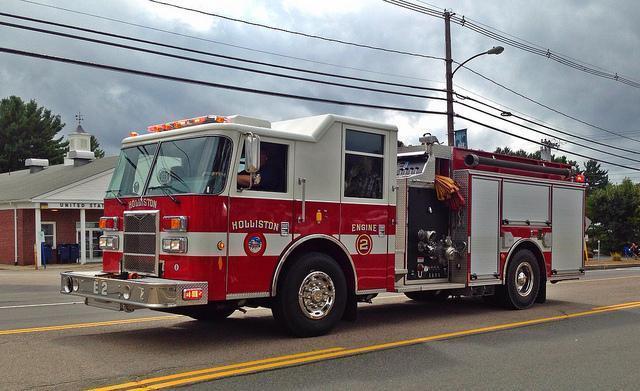How many road lanes are visible in the picture?
Give a very brief answer. 3. 